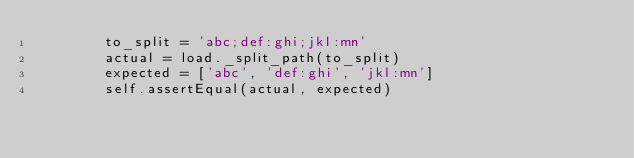<code> <loc_0><loc_0><loc_500><loc_500><_Python_>        to_split = 'abc;def:ghi;jkl:mn'
        actual = load._split_path(to_split)
        expected = ['abc', 'def:ghi', 'jkl:mn']
        self.assertEqual(actual, expected)
</code> 